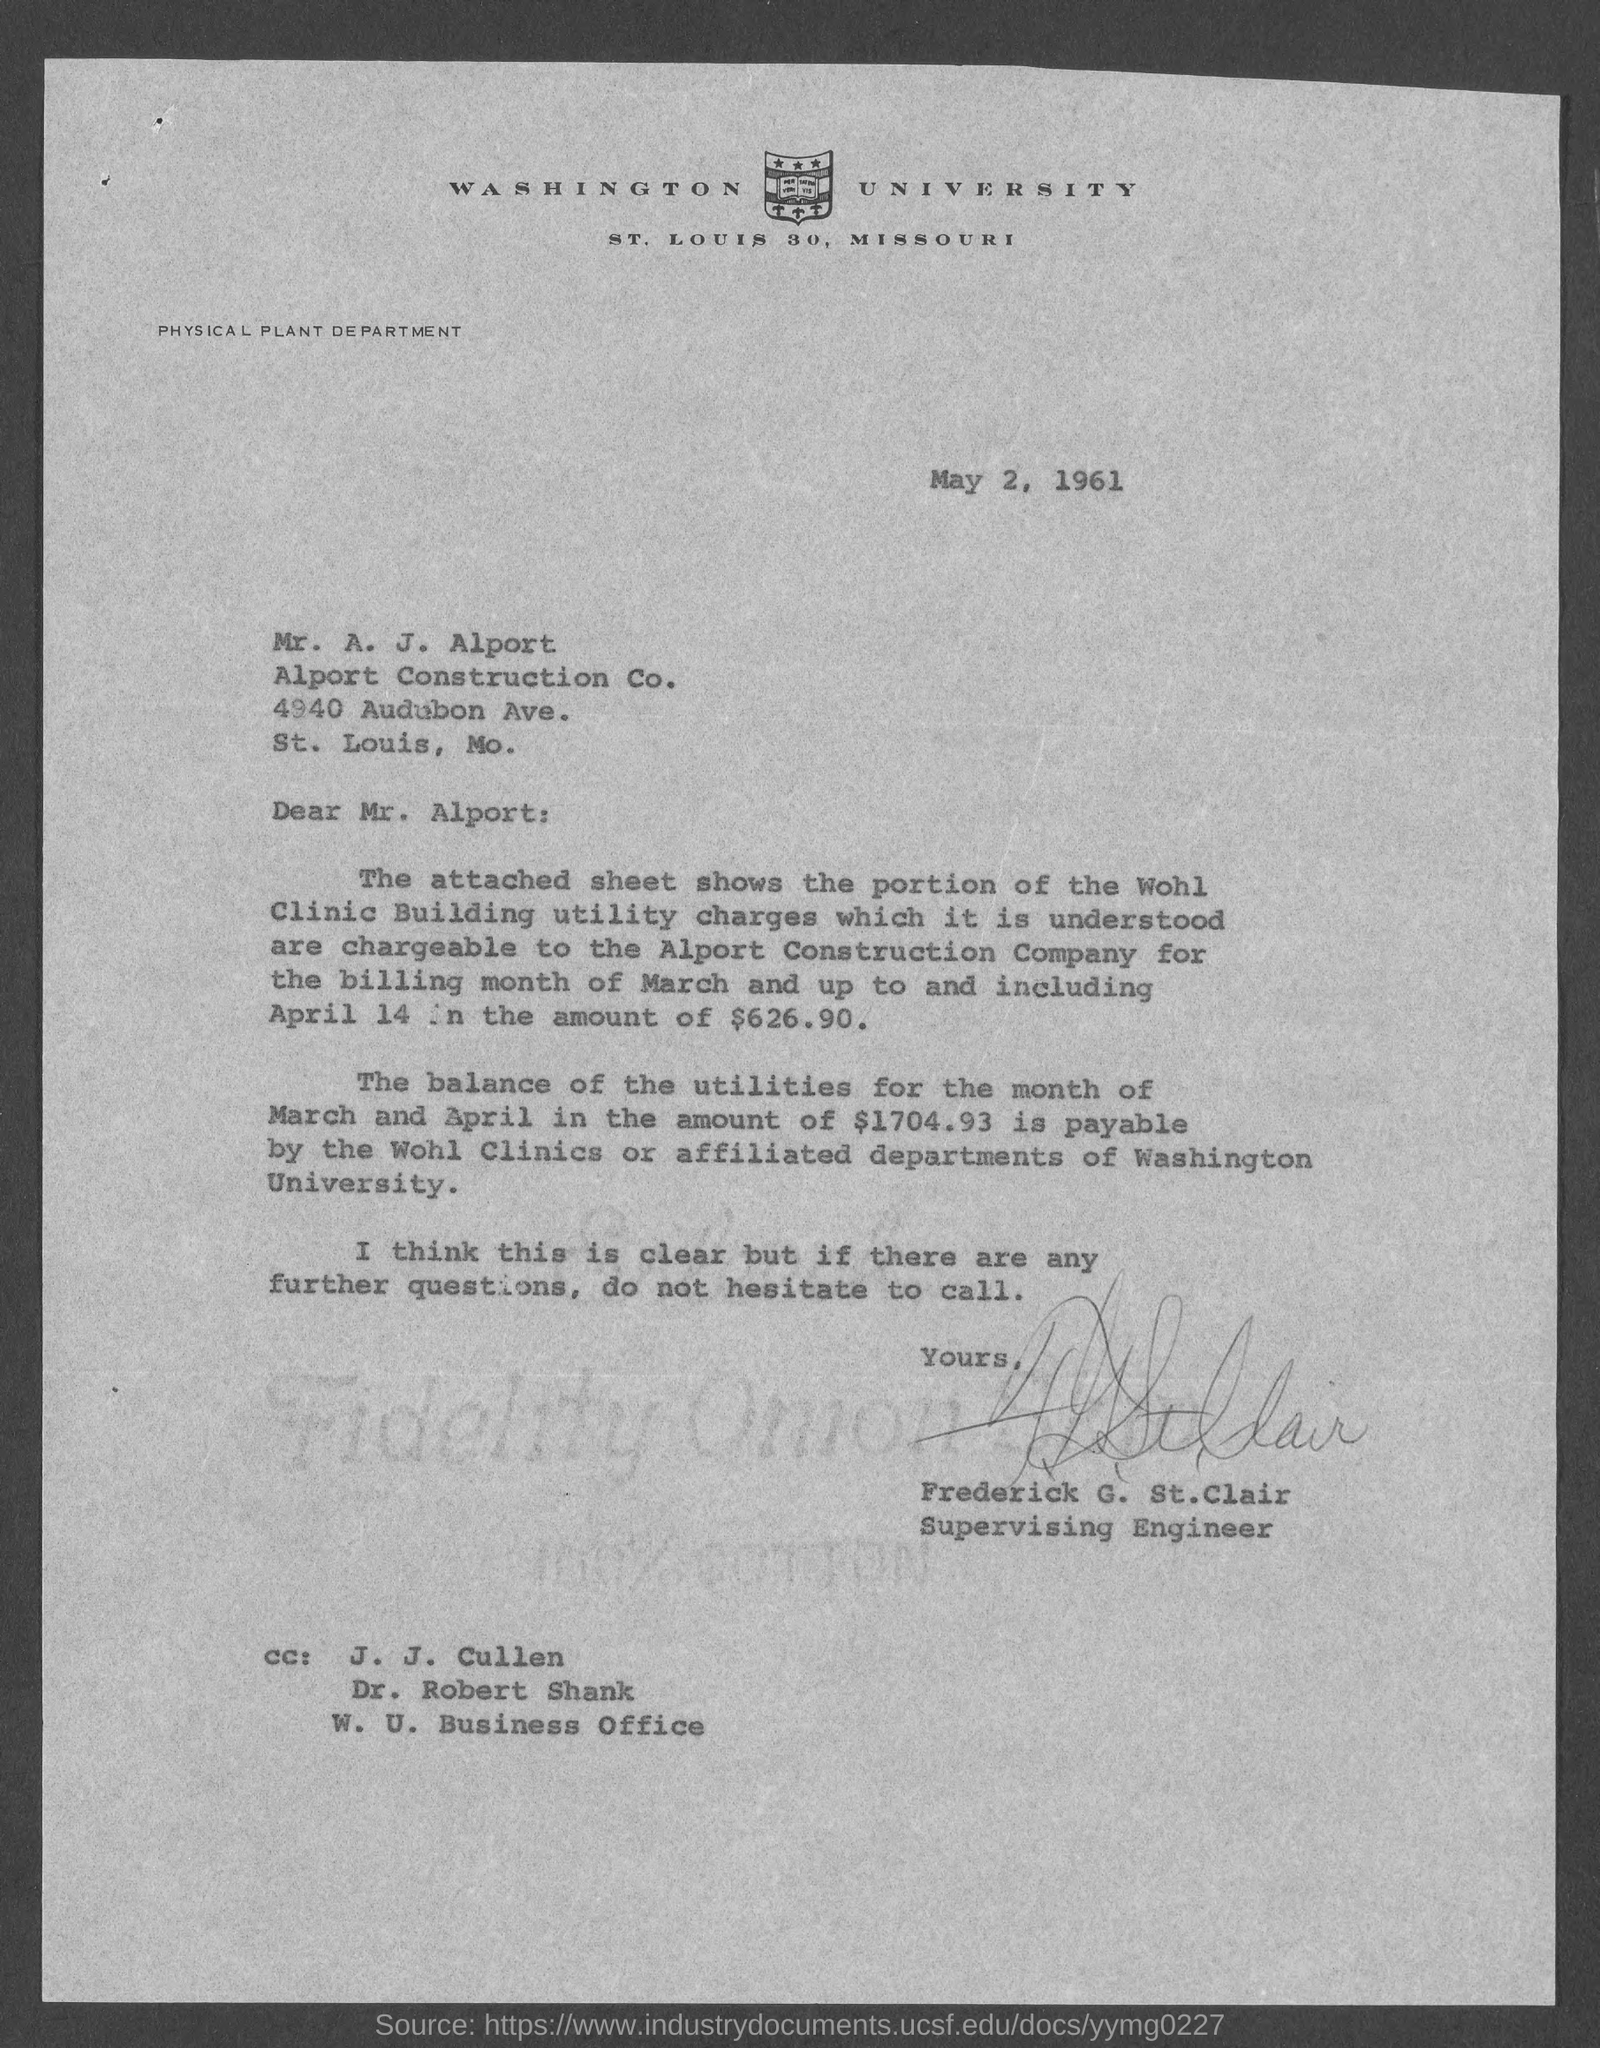List a handful of essential elements in this visual. Frederick G. St.Clair has signed the letter. May 2, 1961, is the date on which the letter was written. 